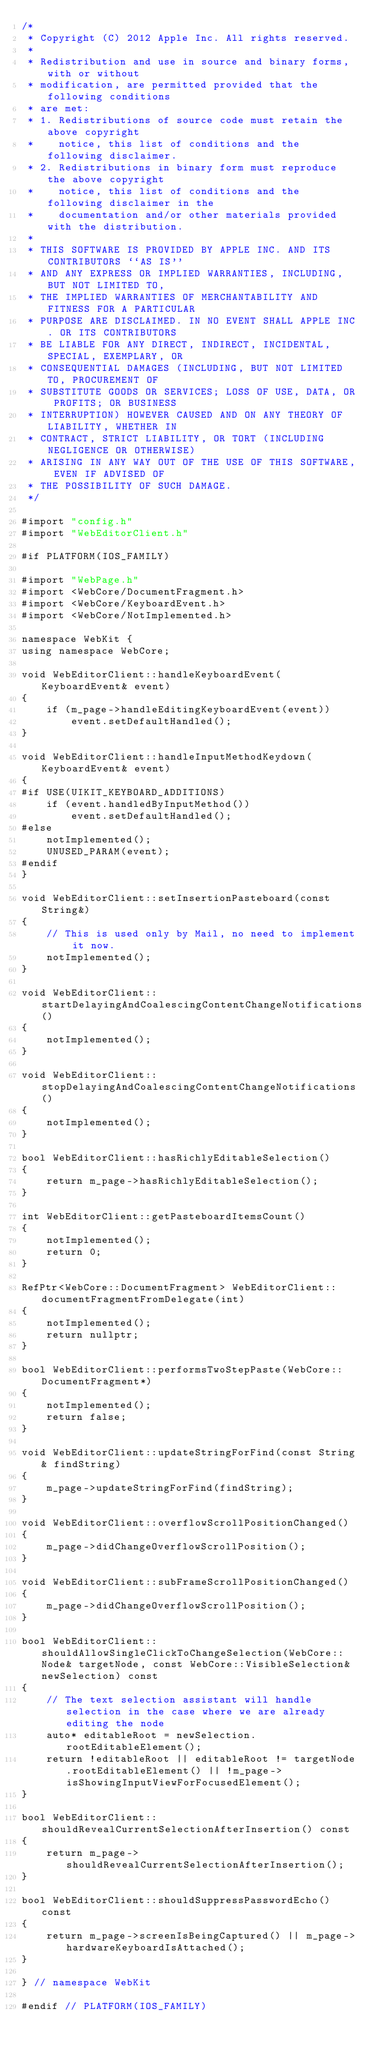Convert code to text. <code><loc_0><loc_0><loc_500><loc_500><_ObjectiveC_>/*
 * Copyright (C) 2012 Apple Inc. All rights reserved.
 *
 * Redistribution and use in source and binary forms, with or without
 * modification, are permitted provided that the following conditions
 * are met:
 * 1. Redistributions of source code must retain the above copyright
 *    notice, this list of conditions and the following disclaimer.
 * 2. Redistributions in binary form must reproduce the above copyright
 *    notice, this list of conditions and the following disclaimer in the
 *    documentation and/or other materials provided with the distribution.
 *
 * THIS SOFTWARE IS PROVIDED BY APPLE INC. AND ITS CONTRIBUTORS ``AS IS''
 * AND ANY EXPRESS OR IMPLIED WARRANTIES, INCLUDING, BUT NOT LIMITED TO,
 * THE IMPLIED WARRANTIES OF MERCHANTABILITY AND FITNESS FOR A PARTICULAR
 * PURPOSE ARE DISCLAIMED. IN NO EVENT SHALL APPLE INC. OR ITS CONTRIBUTORS
 * BE LIABLE FOR ANY DIRECT, INDIRECT, INCIDENTAL, SPECIAL, EXEMPLARY, OR
 * CONSEQUENTIAL DAMAGES (INCLUDING, BUT NOT LIMITED TO, PROCUREMENT OF
 * SUBSTITUTE GOODS OR SERVICES; LOSS OF USE, DATA, OR PROFITS; OR BUSINESS
 * INTERRUPTION) HOWEVER CAUSED AND ON ANY THEORY OF LIABILITY, WHETHER IN
 * CONTRACT, STRICT LIABILITY, OR TORT (INCLUDING NEGLIGENCE OR OTHERWISE)
 * ARISING IN ANY WAY OUT OF THE USE OF THIS SOFTWARE, EVEN IF ADVISED OF
 * THE POSSIBILITY OF SUCH DAMAGE.
 */

#import "config.h"
#import "WebEditorClient.h"

#if PLATFORM(IOS_FAMILY)

#import "WebPage.h"
#import <WebCore/DocumentFragment.h>
#import <WebCore/KeyboardEvent.h>
#import <WebCore/NotImplemented.h>

namespace WebKit {
using namespace WebCore;
    
void WebEditorClient::handleKeyboardEvent(KeyboardEvent& event)
{
    if (m_page->handleEditingKeyboardEvent(event))
        event.setDefaultHandled();
}

void WebEditorClient::handleInputMethodKeydown(KeyboardEvent& event)
{
#if USE(UIKIT_KEYBOARD_ADDITIONS)
    if (event.handledByInputMethod())
        event.setDefaultHandled();
#else
    notImplemented();
    UNUSED_PARAM(event);
#endif
}

void WebEditorClient::setInsertionPasteboard(const String&)
{
    // This is used only by Mail, no need to implement it now.
    notImplemented();
}

void WebEditorClient::startDelayingAndCoalescingContentChangeNotifications()
{
    notImplemented();
}

void WebEditorClient::stopDelayingAndCoalescingContentChangeNotifications()
{
    notImplemented();
}

bool WebEditorClient::hasRichlyEditableSelection()
{
    return m_page->hasRichlyEditableSelection();
}

int WebEditorClient::getPasteboardItemsCount()
{
    notImplemented();
    return 0;
}

RefPtr<WebCore::DocumentFragment> WebEditorClient::documentFragmentFromDelegate(int)
{
    notImplemented();
    return nullptr;
}

bool WebEditorClient::performsTwoStepPaste(WebCore::DocumentFragment*)
{
    notImplemented();
    return false;
}

void WebEditorClient::updateStringForFind(const String& findString)
{
    m_page->updateStringForFind(findString);
}

void WebEditorClient::overflowScrollPositionChanged()
{
    m_page->didChangeOverflowScrollPosition();
}

void WebEditorClient::subFrameScrollPositionChanged()
{
    m_page->didChangeOverflowScrollPosition();
}

bool WebEditorClient::shouldAllowSingleClickToChangeSelection(WebCore::Node& targetNode, const WebCore::VisibleSelection& newSelection) const
{
    // The text selection assistant will handle selection in the case where we are already editing the node
    auto* editableRoot = newSelection.rootEditableElement();
    return !editableRoot || editableRoot != targetNode.rootEditableElement() || !m_page->isShowingInputViewForFocusedElement();
}

bool WebEditorClient::shouldRevealCurrentSelectionAfterInsertion() const
{
    return m_page->shouldRevealCurrentSelectionAfterInsertion();
}

bool WebEditorClient::shouldSuppressPasswordEcho() const
{
    return m_page->screenIsBeingCaptured() || m_page->hardwareKeyboardIsAttached();
}

} // namespace WebKit

#endif // PLATFORM(IOS_FAMILY)
</code> 